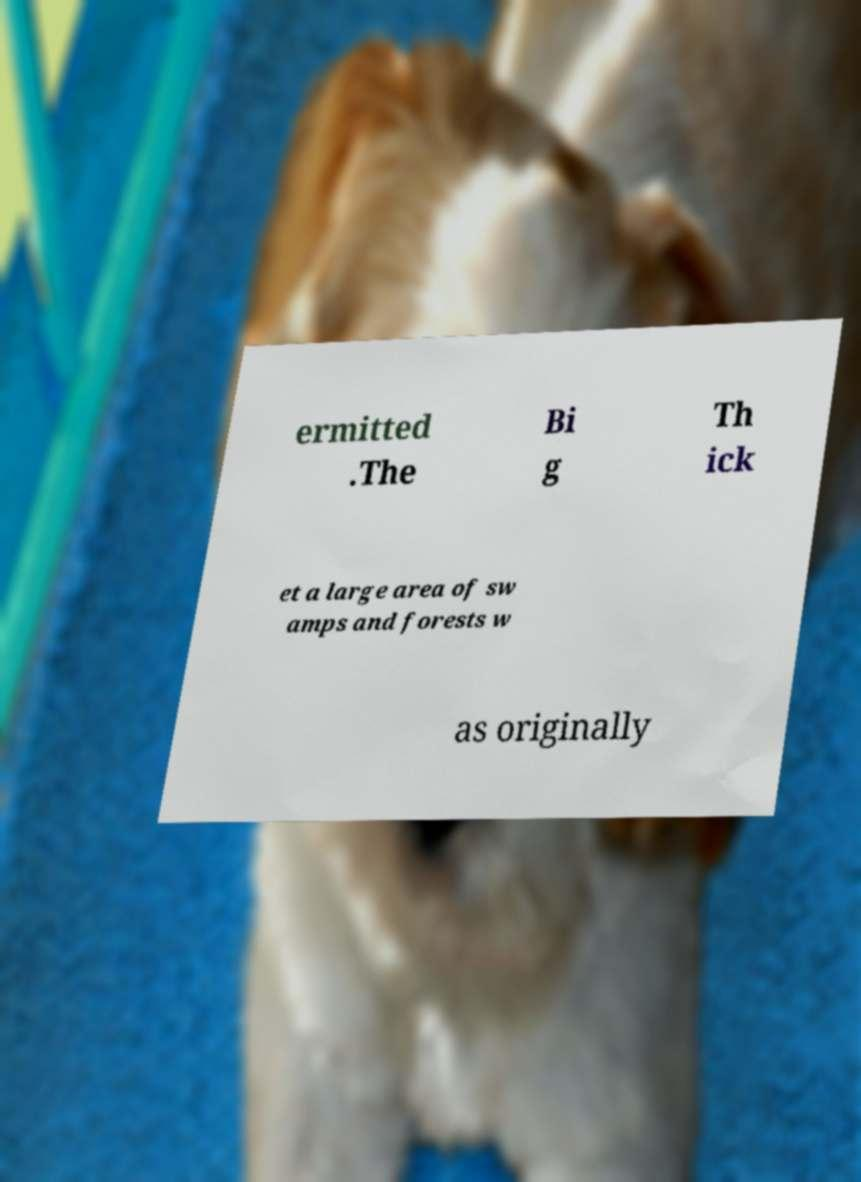Could you assist in decoding the text presented in this image and type it out clearly? ermitted .The Bi g Th ick et a large area of sw amps and forests w as originally 